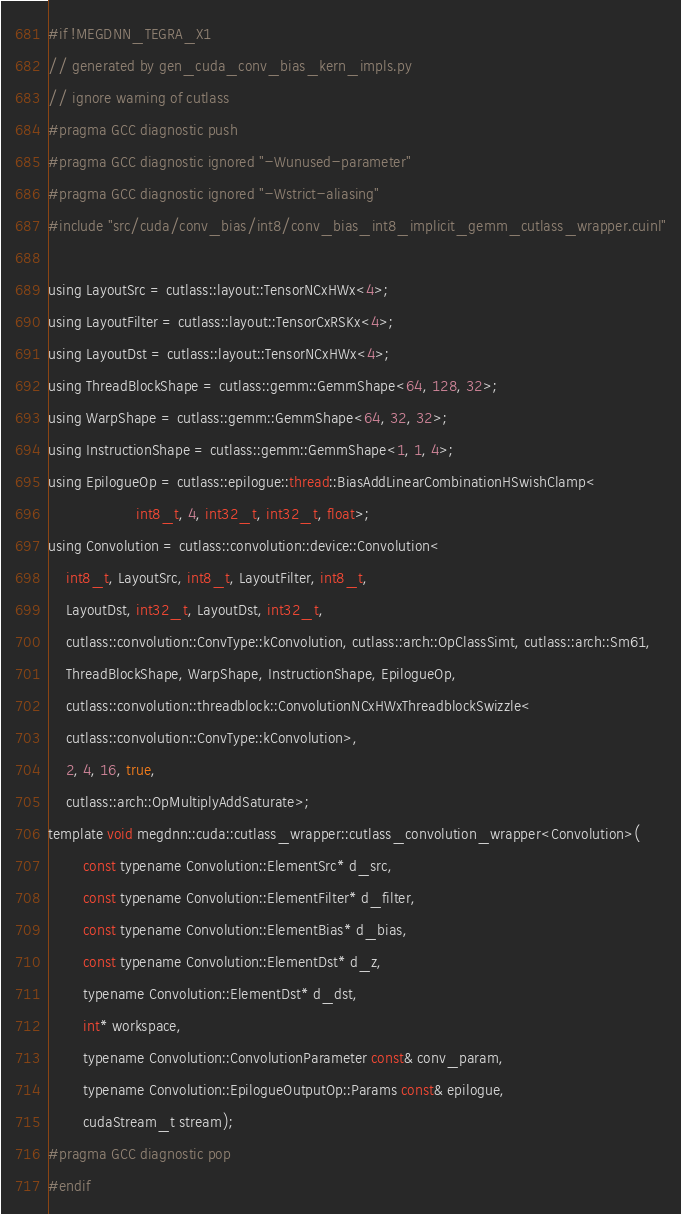Convert code to text. <code><loc_0><loc_0><loc_500><loc_500><_Cuda_>#if !MEGDNN_TEGRA_X1
// generated by gen_cuda_conv_bias_kern_impls.py
// ignore warning of cutlass
#pragma GCC diagnostic push
#pragma GCC diagnostic ignored "-Wunused-parameter"
#pragma GCC diagnostic ignored "-Wstrict-aliasing"
#include "src/cuda/conv_bias/int8/conv_bias_int8_implicit_gemm_cutlass_wrapper.cuinl"

using LayoutSrc = cutlass::layout::TensorNCxHWx<4>;
using LayoutFilter = cutlass::layout::TensorCxRSKx<4>;
using LayoutDst = cutlass::layout::TensorNCxHWx<4>;
using ThreadBlockShape = cutlass::gemm::GemmShape<64, 128, 32>;
using WarpShape = cutlass::gemm::GemmShape<64, 32, 32>;
using InstructionShape = cutlass::gemm::GemmShape<1, 1, 4>;
using EpilogueOp = cutlass::epilogue::thread::BiasAddLinearCombinationHSwishClamp<
                    int8_t, 4, int32_t, int32_t, float>;
using Convolution = cutlass::convolution::device::Convolution<
    int8_t, LayoutSrc, int8_t, LayoutFilter, int8_t, 
    LayoutDst, int32_t, LayoutDst, int32_t, 
    cutlass::convolution::ConvType::kConvolution, cutlass::arch::OpClassSimt, cutlass::arch::Sm61, 
    ThreadBlockShape, WarpShape, InstructionShape, EpilogueOp, 
    cutlass::convolution::threadblock::ConvolutionNCxHWxThreadblockSwizzle<
    cutlass::convolution::ConvType::kConvolution>, 
    2, 4, 16, true, 
    cutlass::arch::OpMultiplyAddSaturate>;
template void megdnn::cuda::cutlass_wrapper::cutlass_convolution_wrapper<Convolution>(
        const typename Convolution::ElementSrc* d_src, 
        const typename Convolution::ElementFilter* d_filter, 
        const typename Convolution::ElementBias* d_bias, 
        const typename Convolution::ElementDst* d_z, 
        typename Convolution::ElementDst* d_dst, 
        int* workspace, 
        typename Convolution::ConvolutionParameter const& conv_param, 
        typename Convolution::EpilogueOutputOp::Params const& epilogue, 
        cudaStream_t stream);
#pragma GCC diagnostic pop
#endif
</code> 